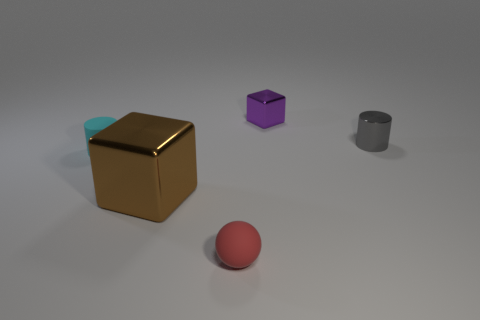Add 2 large shiny cubes. How many objects exist? 7 Subtract all cubes. How many objects are left? 3 Add 2 small red matte objects. How many small red matte objects are left? 3 Add 5 tiny red things. How many tiny red things exist? 6 Subtract 0 red cubes. How many objects are left? 5 Subtract all small blue objects. Subtract all large things. How many objects are left? 4 